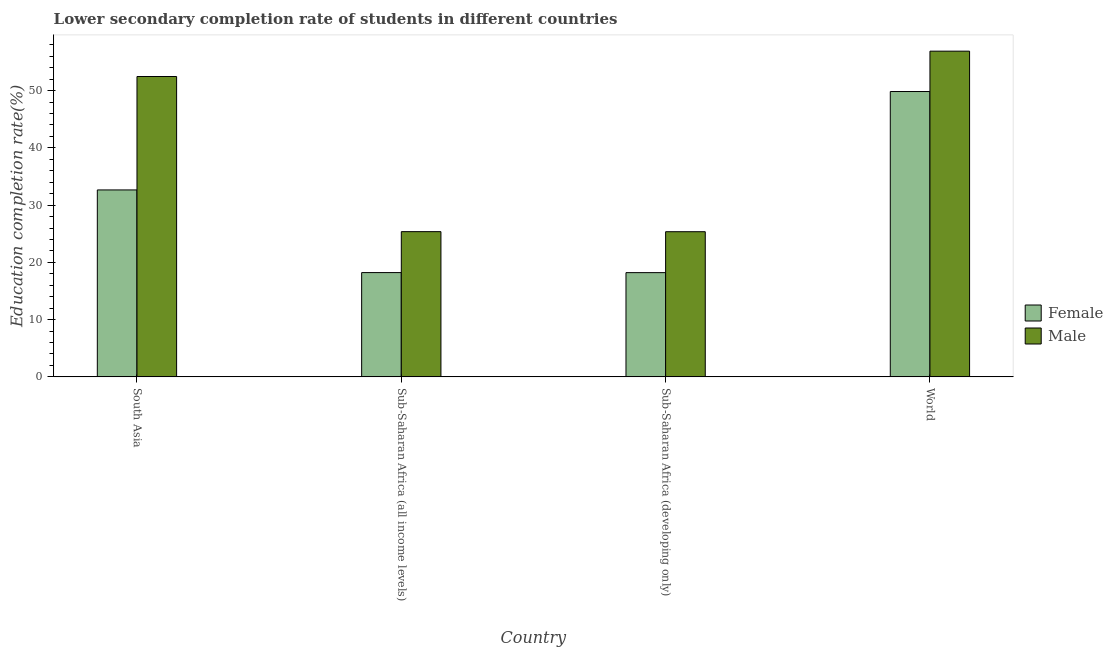How many different coloured bars are there?
Ensure brevity in your answer.  2. How many groups of bars are there?
Your answer should be very brief. 4. Are the number of bars per tick equal to the number of legend labels?
Provide a succinct answer. Yes. How many bars are there on the 2nd tick from the left?
Give a very brief answer. 2. How many bars are there on the 4th tick from the right?
Keep it short and to the point. 2. What is the label of the 2nd group of bars from the left?
Ensure brevity in your answer.  Sub-Saharan Africa (all income levels). In how many cases, is the number of bars for a given country not equal to the number of legend labels?
Keep it short and to the point. 0. What is the education completion rate of female students in Sub-Saharan Africa (all income levels)?
Make the answer very short. 18.21. Across all countries, what is the maximum education completion rate of male students?
Provide a short and direct response. 56.89. Across all countries, what is the minimum education completion rate of female students?
Give a very brief answer. 18.21. In which country was the education completion rate of male students minimum?
Offer a very short reply. Sub-Saharan Africa (developing only). What is the total education completion rate of male students in the graph?
Your response must be concise. 160.06. What is the difference between the education completion rate of female students in Sub-Saharan Africa (developing only) and that in World?
Your answer should be very brief. -31.63. What is the difference between the education completion rate of female students in Sub-Saharan Africa (all income levels) and the education completion rate of male students in South Asia?
Make the answer very short. -34.24. What is the average education completion rate of male students per country?
Offer a terse response. 40.02. What is the difference between the education completion rate of female students and education completion rate of male students in World?
Offer a very short reply. -7.05. In how many countries, is the education completion rate of female students greater than 10 %?
Your response must be concise. 4. What is the ratio of the education completion rate of male students in South Asia to that in Sub-Saharan Africa (all income levels)?
Make the answer very short. 2.07. Is the difference between the education completion rate of female students in South Asia and World greater than the difference between the education completion rate of male students in South Asia and World?
Keep it short and to the point. No. What is the difference between the highest and the second highest education completion rate of male students?
Ensure brevity in your answer.  4.43. What is the difference between the highest and the lowest education completion rate of male students?
Offer a very short reply. 31.53. What does the 2nd bar from the right in South Asia represents?
Keep it short and to the point. Female. How many countries are there in the graph?
Your answer should be compact. 4. How many legend labels are there?
Make the answer very short. 2. How are the legend labels stacked?
Offer a terse response. Vertical. What is the title of the graph?
Ensure brevity in your answer.  Lower secondary completion rate of students in different countries. Does "Under-5(female)" appear as one of the legend labels in the graph?
Ensure brevity in your answer.  No. What is the label or title of the X-axis?
Make the answer very short. Country. What is the label or title of the Y-axis?
Offer a terse response. Education completion rate(%). What is the Education completion rate(%) of Female in South Asia?
Provide a short and direct response. 32.65. What is the Education completion rate(%) of Male in South Asia?
Your answer should be compact. 52.46. What is the Education completion rate(%) of Female in Sub-Saharan Africa (all income levels)?
Give a very brief answer. 18.21. What is the Education completion rate(%) in Male in Sub-Saharan Africa (all income levels)?
Your response must be concise. 25.36. What is the Education completion rate(%) of Female in Sub-Saharan Africa (developing only)?
Make the answer very short. 18.21. What is the Education completion rate(%) of Male in Sub-Saharan Africa (developing only)?
Keep it short and to the point. 25.35. What is the Education completion rate(%) of Female in World?
Ensure brevity in your answer.  49.84. What is the Education completion rate(%) of Male in World?
Your answer should be compact. 56.89. Across all countries, what is the maximum Education completion rate(%) in Female?
Your answer should be very brief. 49.84. Across all countries, what is the maximum Education completion rate(%) of Male?
Offer a terse response. 56.89. Across all countries, what is the minimum Education completion rate(%) of Female?
Offer a very short reply. 18.21. Across all countries, what is the minimum Education completion rate(%) in Male?
Provide a succinct answer. 25.35. What is the total Education completion rate(%) of Female in the graph?
Your response must be concise. 118.91. What is the total Education completion rate(%) of Male in the graph?
Make the answer very short. 160.06. What is the difference between the Education completion rate(%) of Female in South Asia and that in Sub-Saharan Africa (all income levels)?
Make the answer very short. 14.44. What is the difference between the Education completion rate(%) in Male in South Asia and that in Sub-Saharan Africa (all income levels)?
Your answer should be very brief. 27.09. What is the difference between the Education completion rate(%) in Female in South Asia and that in Sub-Saharan Africa (developing only)?
Your answer should be compact. 14.44. What is the difference between the Education completion rate(%) in Male in South Asia and that in Sub-Saharan Africa (developing only)?
Provide a succinct answer. 27.1. What is the difference between the Education completion rate(%) of Female in South Asia and that in World?
Your response must be concise. -17.19. What is the difference between the Education completion rate(%) in Male in South Asia and that in World?
Your response must be concise. -4.43. What is the difference between the Education completion rate(%) of Female in Sub-Saharan Africa (all income levels) and that in Sub-Saharan Africa (developing only)?
Offer a terse response. 0.01. What is the difference between the Education completion rate(%) of Male in Sub-Saharan Africa (all income levels) and that in Sub-Saharan Africa (developing only)?
Your answer should be compact. 0.01. What is the difference between the Education completion rate(%) of Female in Sub-Saharan Africa (all income levels) and that in World?
Your answer should be very brief. -31.62. What is the difference between the Education completion rate(%) in Male in Sub-Saharan Africa (all income levels) and that in World?
Ensure brevity in your answer.  -31.52. What is the difference between the Education completion rate(%) of Female in Sub-Saharan Africa (developing only) and that in World?
Your answer should be compact. -31.63. What is the difference between the Education completion rate(%) in Male in Sub-Saharan Africa (developing only) and that in World?
Give a very brief answer. -31.53. What is the difference between the Education completion rate(%) of Female in South Asia and the Education completion rate(%) of Male in Sub-Saharan Africa (all income levels)?
Give a very brief answer. 7.29. What is the difference between the Education completion rate(%) in Female in South Asia and the Education completion rate(%) in Male in Sub-Saharan Africa (developing only)?
Give a very brief answer. 7.3. What is the difference between the Education completion rate(%) of Female in South Asia and the Education completion rate(%) of Male in World?
Your answer should be compact. -24.24. What is the difference between the Education completion rate(%) in Female in Sub-Saharan Africa (all income levels) and the Education completion rate(%) in Male in Sub-Saharan Africa (developing only)?
Provide a short and direct response. -7.14. What is the difference between the Education completion rate(%) of Female in Sub-Saharan Africa (all income levels) and the Education completion rate(%) of Male in World?
Offer a very short reply. -38.67. What is the difference between the Education completion rate(%) of Female in Sub-Saharan Africa (developing only) and the Education completion rate(%) of Male in World?
Provide a succinct answer. -38.68. What is the average Education completion rate(%) in Female per country?
Make the answer very short. 29.73. What is the average Education completion rate(%) in Male per country?
Provide a short and direct response. 40.02. What is the difference between the Education completion rate(%) in Female and Education completion rate(%) in Male in South Asia?
Your answer should be very brief. -19.81. What is the difference between the Education completion rate(%) of Female and Education completion rate(%) of Male in Sub-Saharan Africa (all income levels)?
Ensure brevity in your answer.  -7.15. What is the difference between the Education completion rate(%) in Female and Education completion rate(%) in Male in Sub-Saharan Africa (developing only)?
Offer a very short reply. -7.15. What is the difference between the Education completion rate(%) in Female and Education completion rate(%) in Male in World?
Offer a very short reply. -7.05. What is the ratio of the Education completion rate(%) in Female in South Asia to that in Sub-Saharan Africa (all income levels)?
Your answer should be compact. 1.79. What is the ratio of the Education completion rate(%) in Male in South Asia to that in Sub-Saharan Africa (all income levels)?
Provide a short and direct response. 2.07. What is the ratio of the Education completion rate(%) of Female in South Asia to that in Sub-Saharan Africa (developing only)?
Make the answer very short. 1.79. What is the ratio of the Education completion rate(%) of Male in South Asia to that in Sub-Saharan Africa (developing only)?
Give a very brief answer. 2.07. What is the ratio of the Education completion rate(%) in Female in South Asia to that in World?
Provide a short and direct response. 0.66. What is the ratio of the Education completion rate(%) in Male in South Asia to that in World?
Ensure brevity in your answer.  0.92. What is the ratio of the Education completion rate(%) of Female in Sub-Saharan Africa (all income levels) to that in Sub-Saharan Africa (developing only)?
Make the answer very short. 1. What is the ratio of the Education completion rate(%) of Female in Sub-Saharan Africa (all income levels) to that in World?
Your answer should be very brief. 0.37. What is the ratio of the Education completion rate(%) in Male in Sub-Saharan Africa (all income levels) to that in World?
Provide a short and direct response. 0.45. What is the ratio of the Education completion rate(%) of Female in Sub-Saharan Africa (developing only) to that in World?
Provide a short and direct response. 0.37. What is the ratio of the Education completion rate(%) of Male in Sub-Saharan Africa (developing only) to that in World?
Your answer should be compact. 0.45. What is the difference between the highest and the second highest Education completion rate(%) of Female?
Keep it short and to the point. 17.19. What is the difference between the highest and the second highest Education completion rate(%) in Male?
Your answer should be compact. 4.43. What is the difference between the highest and the lowest Education completion rate(%) of Female?
Provide a succinct answer. 31.63. What is the difference between the highest and the lowest Education completion rate(%) in Male?
Your answer should be compact. 31.53. 